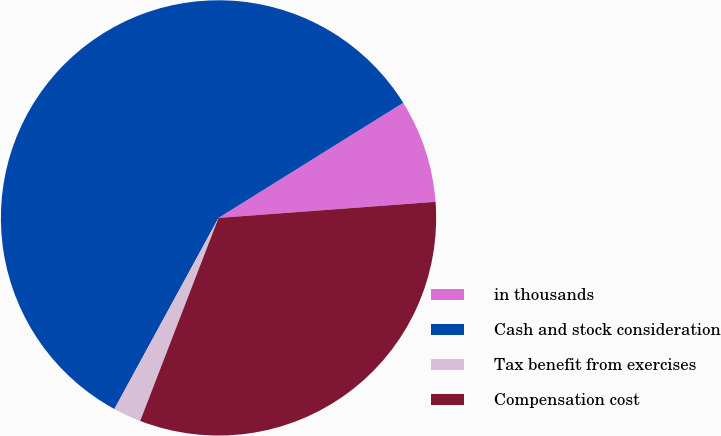Convert chart to OTSL. <chart><loc_0><loc_0><loc_500><loc_500><pie_chart><fcel>in thousands<fcel>Cash and stock consideration<fcel>Tax benefit from exercises<fcel>Compensation cost<nl><fcel>7.69%<fcel>58.19%<fcel>2.08%<fcel>32.04%<nl></chart> 